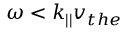Convert formula to latex. <formula><loc_0><loc_0><loc_500><loc_500>\omega < k _ { | | } v _ { t h e }</formula> 